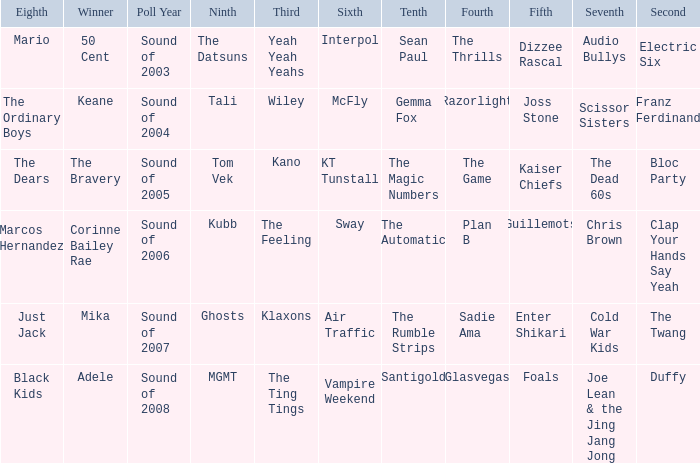Write the full table. {'header': ['Eighth', 'Winner', 'Poll Year', 'Ninth', 'Third', 'Sixth', 'Tenth', 'Fourth', 'Fifth', 'Seventh', 'Second'], 'rows': [['Mario', '50 Cent', 'Sound of 2003', 'The Datsuns', 'Yeah Yeah Yeahs', 'Interpol', 'Sean Paul', 'The Thrills', 'Dizzee Rascal', 'Audio Bullys', 'Electric Six'], ['The Ordinary Boys', 'Keane', 'Sound of 2004', 'Tali', 'Wiley', 'McFly', 'Gemma Fox', 'Razorlight', 'Joss Stone', 'Scissor Sisters', 'Franz Ferdinand'], ['The Dears', 'The Bravery', 'Sound of 2005', 'Tom Vek', 'Kano', 'KT Tunstall', 'The Magic Numbers', 'The Game', 'Kaiser Chiefs', 'The Dead 60s', 'Bloc Party'], ['Marcos Hernandez', 'Corinne Bailey Rae', 'Sound of 2006', 'Kubb', 'The Feeling', 'Sway', 'The Automatic', 'Plan B', 'Guillemots', 'Chris Brown', 'Clap Your Hands Say Yeah'], ['Just Jack', 'Mika', 'Sound of 2007', 'Ghosts', 'Klaxons', 'Air Traffic', 'The Rumble Strips', 'Sadie Ama', 'Enter Shikari', 'Cold War Kids', 'The Twang'], ['Black Kids', 'Adele', 'Sound of 2008', 'MGMT', 'The Ting Tings', 'Vampire Weekend', 'Santigold', 'Glasvegas', 'Foals', 'Joe Lean & the Jing Jang Jong', 'Duffy']]} When Interpol is in 6th, who is in 7th? 1.0. 